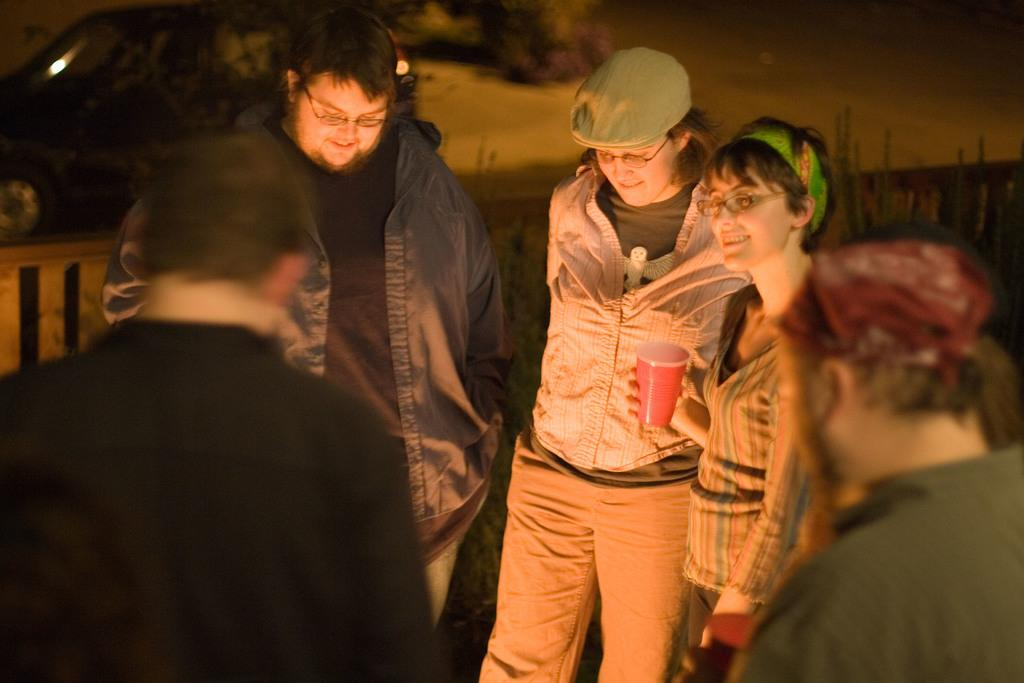How many people are in the image? There is a group of people in the image. What are the people in the image doing? The people are standing around. Can you describe the woman in the group? The woman is in the group, and she is holding a glass with her hand. What type of cherry is the woman holding in the image? The woman is not holding a cherry in the image; she is holding a glass with her hand. 